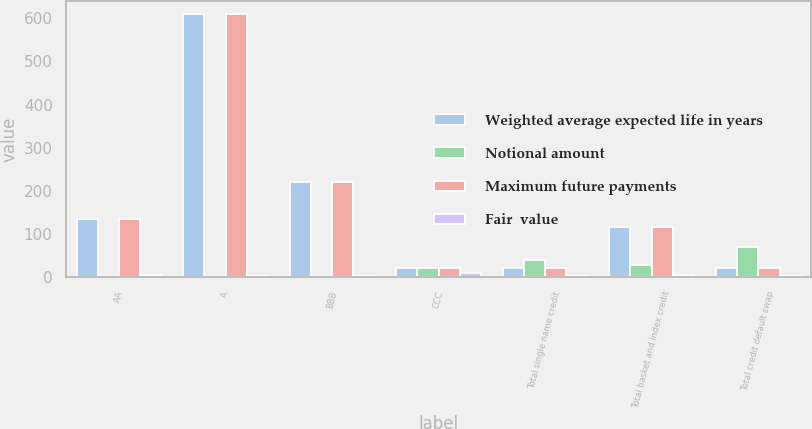<chart> <loc_0><loc_0><loc_500><loc_500><stacked_bar_chart><ecel><fcel>AA<fcel>A<fcel>BBB<fcel>CCC<fcel>Total single name credit<fcel>Total basket and index credit<fcel>Total credit default swap<nl><fcel>Weighted average expected life in years<fcel>135<fcel>609<fcel>220<fcel>22<fcel>22<fcel>116<fcel>22<nl><fcel>Notional amount<fcel>0.6<fcel>1.2<fcel>0.2<fcel>20.2<fcel>40.6<fcel>28.4<fcel>69<nl><fcel>Maximum future payments<fcel>135<fcel>609<fcel>220<fcel>22<fcel>22<fcel>116<fcel>22<nl><fcel>Fair  value<fcel>4.9<fcel>3.6<fcel>1.8<fcel>10.4<fcel>3.6<fcel>4.4<fcel>3.6<nl></chart> 